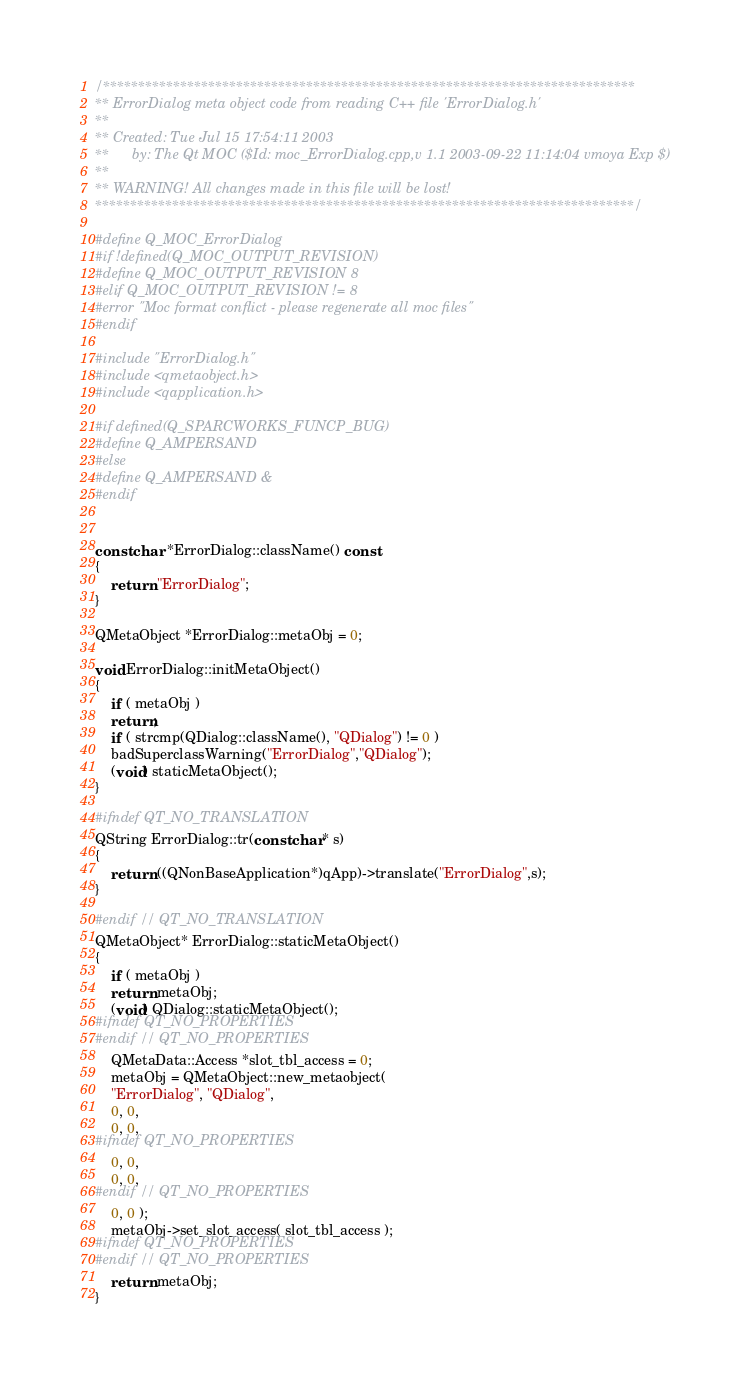Convert code to text. <code><loc_0><loc_0><loc_500><loc_500><_C++_>/****************************************************************************
** ErrorDialog meta object code from reading C++ file 'ErrorDialog.h'
**
** Created: Tue Jul 15 17:54:11 2003
**      by: The Qt MOC ($Id: moc_ErrorDialog.cpp,v 1.1 2003-09-22 11:14:04 vmoya Exp $)
**
** WARNING! All changes made in this file will be lost!
*****************************************************************************/

#define Q_MOC_ErrorDialog
#if !defined(Q_MOC_OUTPUT_REVISION)
#define Q_MOC_OUTPUT_REVISION 8
#elif Q_MOC_OUTPUT_REVISION != 8
#error "Moc format conflict - please regenerate all moc files"
#endif

#include "ErrorDialog.h"
#include <qmetaobject.h>
#include <qapplication.h>

#if defined(Q_SPARCWORKS_FUNCP_BUG)
#define Q_AMPERSAND
#else
#define Q_AMPERSAND &
#endif


const char *ErrorDialog::className() const
{
    return "ErrorDialog";
}

QMetaObject *ErrorDialog::metaObj = 0;

void ErrorDialog::initMetaObject()
{
    if ( metaObj )
	return;
    if ( strcmp(QDialog::className(), "QDialog") != 0 )
	badSuperclassWarning("ErrorDialog","QDialog");
    (void) staticMetaObject();
}

#ifndef QT_NO_TRANSLATION
QString ErrorDialog::tr(const char* s)
{
    return ((QNonBaseApplication*)qApp)->translate("ErrorDialog",s);
}

#endif // QT_NO_TRANSLATION
QMetaObject* ErrorDialog::staticMetaObject()
{
    if ( metaObj )
	return metaObj;
    (void) QDialog::staticMetaObject();
#ifndef QT_NO_PROPERTIES
#endif // QT_NO_PROPERTIES
    QMetaData::Access *slot_tbl_access = 0;
    metaObj = QMetaObject::new_metaobject(
	"ErrorDialog", "QDialog",
	0, 0,
	0, 0,
#ifndef QT_NO_PROPERTIES
	0, 0,
	0, 0,
#endif // QT_NO_PROPERTIES
	0, 0 );
    metaObj->set_slot_access( slot_tbl_access );
#ifndef QT_NO_PROPERTIES
#endif // QT_NO_PROPERTIES
    return metaObj;
}
</code> 